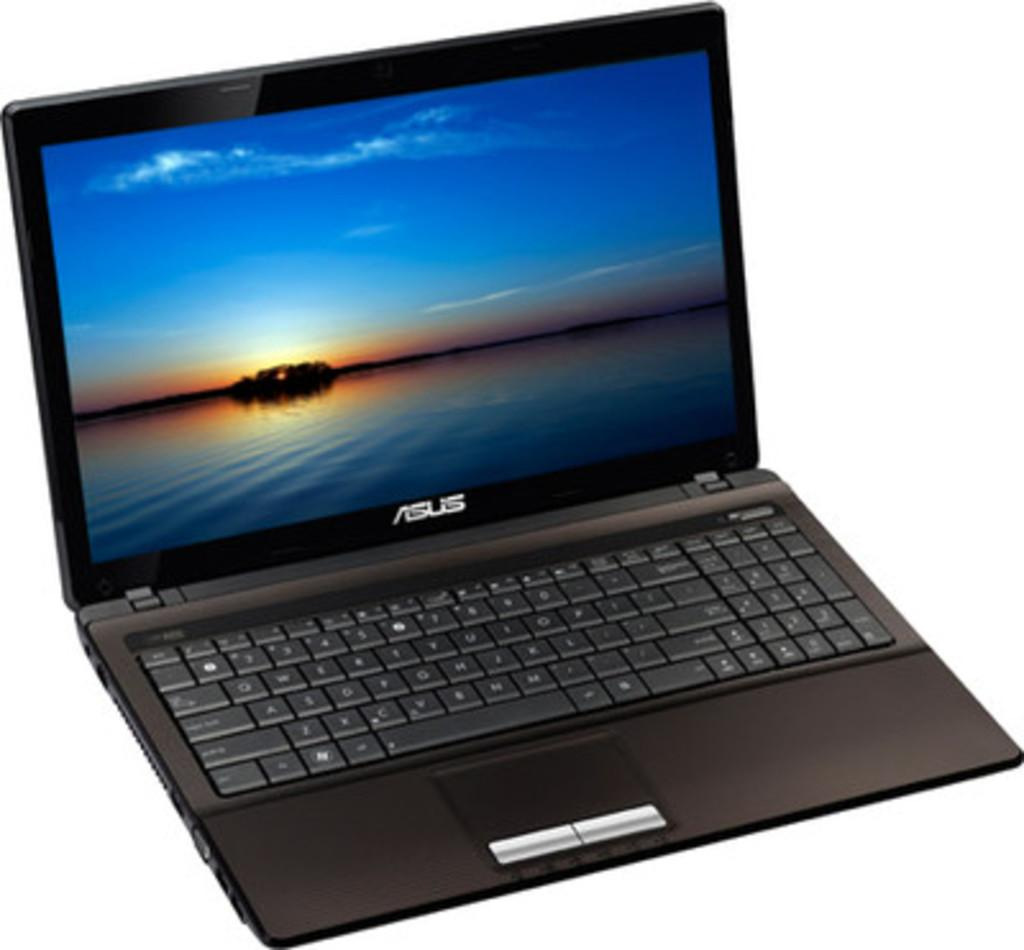<image>
Give a short and clear explanation of the subsequent image. a laptop that has the word Asus written on it 